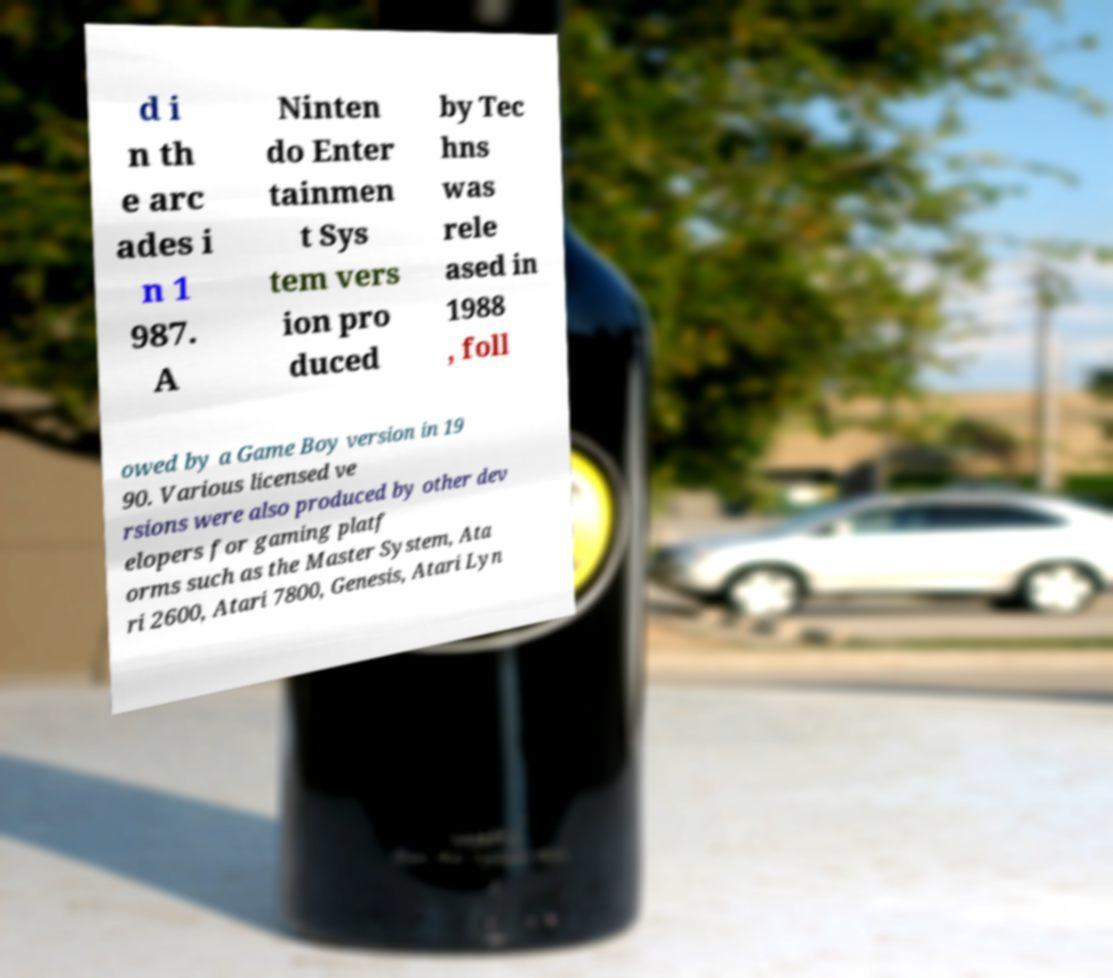Could you extract and type out the text from this image? d i n th e arc ades i n 1 987. A Ninten do Enter tainmen t Sys tem vers ion pro duced by Tec hns was rele ased in 1988 , foll owed by a Game Boy version in 19 90. Various licensed ve rsions were also produced by other dev elopers for gaming platf orms such as the Master System, Ata ri 2600, Atari 7800, Genesis, Atari Lyn 